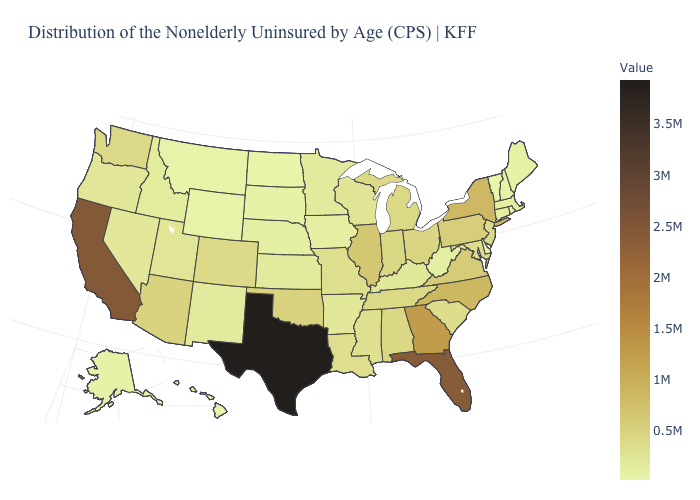Which states hav the highest value in the West?
Concise answer only. California. Among the states that border New Hampshire , which have the highest value?
Short answer required. Massachusetts. Does Indiana have a higher value than Texas?
Write a very short answer. No. Does the map have missing data?
Short answer required. No. 